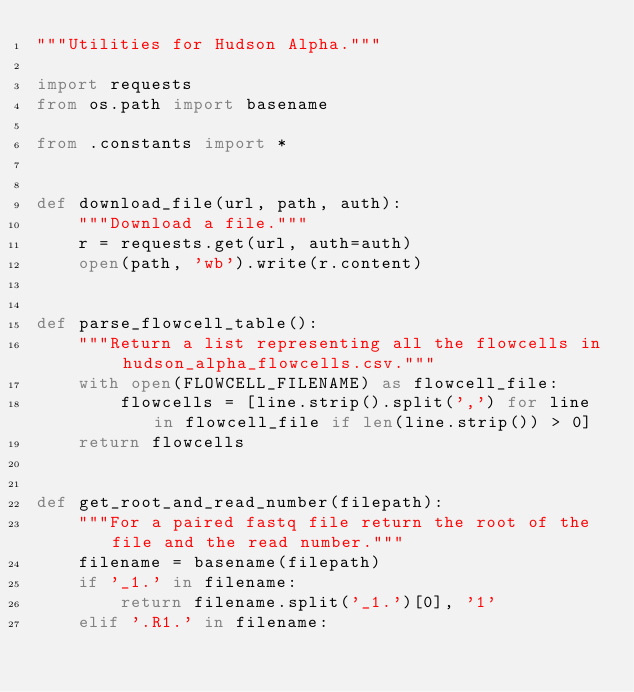<code> <loc_0><loc_0><loc_500><loc_500><_Python_>"""Utilities for Hudson Alpha."""

import requests
from os.path import basename

from .constants import *


def download_file(url, path, auth):
    """Download a file."""
    r = requests.get(url, auth=auth)
    open(path, 'wb').write(r.content)


def parse_flowcell_table():
    """Return a list representing all the flowcells in hudson_alpha_flowcells.csv."""
    with open(FLOWCELL_FILENAME) as flowcell_file:
        flowcells = [line.strip().split(',') for line in flowcell_file if len(line.strip()) > 0]
    return flowcells


def get_root_and_read_number(filepath):
    """For a paired fastq file return the root of the file and the read number."""
    filename = basename(filepath)
    if '_1.' in filename:
        return filename.split('_1.')[0], '1'
    elif '.R1.' in filename:</code> 